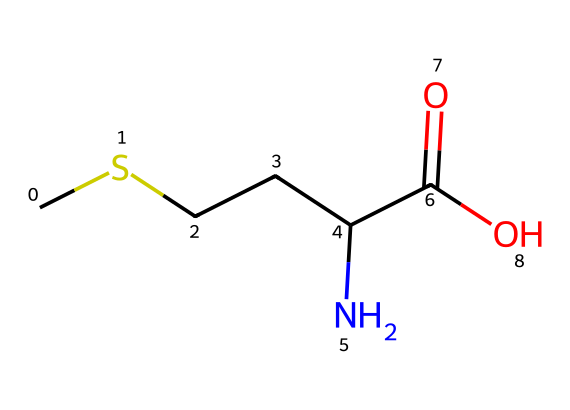What is the primary functional group present in methionine? The SMILES representation CSCCC(N)C(=O)O contains a carboxylic acid group (C(=O)O) at one end, indicating that methionine has a carboxylic acid functional group.
Answer: carboxylic acid How many carbon atoms are in methionine? Analyzing the SMILES representation, there are a total of five carbon (C) atoms, as indicated by the 'C' characters.
Answer: 5 What is the total number of nitrogen atoms in methionine? The SMILES includes one nitrogen atom as represented by 'N'. Therefore, there is a total of one nitrogen atom in methionine.
Answer: 1 What type of molecule is methionine? Given that methionine contains both amino (NH2) and carboxylic acid (COOH) functional groups, it is classified as an amino acid.
Answer: amino acid How many oxygen atoms are present in methionine? The SMILES representation includes two oxygen atoms indicated by 'O' in the carboxylic acid functional group.
Answer: 2 What type of organosulfur compound does methionine represent? Methionine is an organosulfur amino acid due to the presence of a sulfur atom (represented by 'S') in its side chain, making it an essential component of proteins.
Answer: organosulfur amino acid How does the presence of sulfur in methionine affect its properties? The sulfur atom in methionine provides unique properties such as the formation of disulfide bonds when oxidized, which can influence protein structure and stability.
Answer: disulfide bonds 